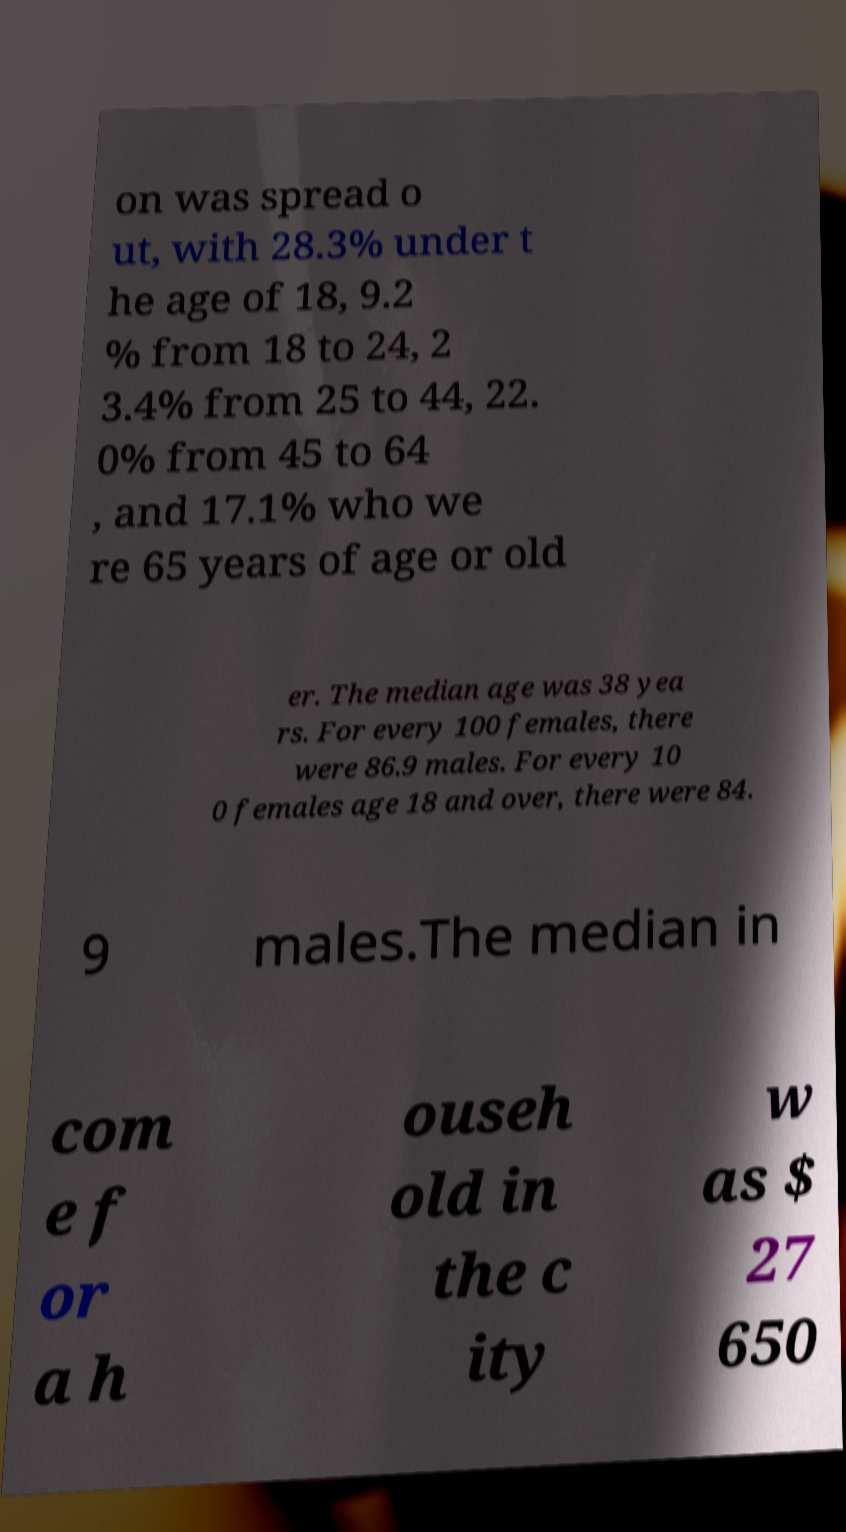What messages or text are displayed in this image? I need them in a readable, typed format. on was spread o ut, with 28.3% under t he age of 18, 9.2 % from 18 to 24, 2 3.4% from 25 to 44, 22. 0% from 45 to 64 , and 17.1% who we re 65 years of age or old er. The median age was 38 yea rs. For every 100 females, there were 86.9 males. For every 10 0 females age 18 and over, there were 84. 9 males.The median in com e f or a h ouseh old in the c ity w as $ 27 650 